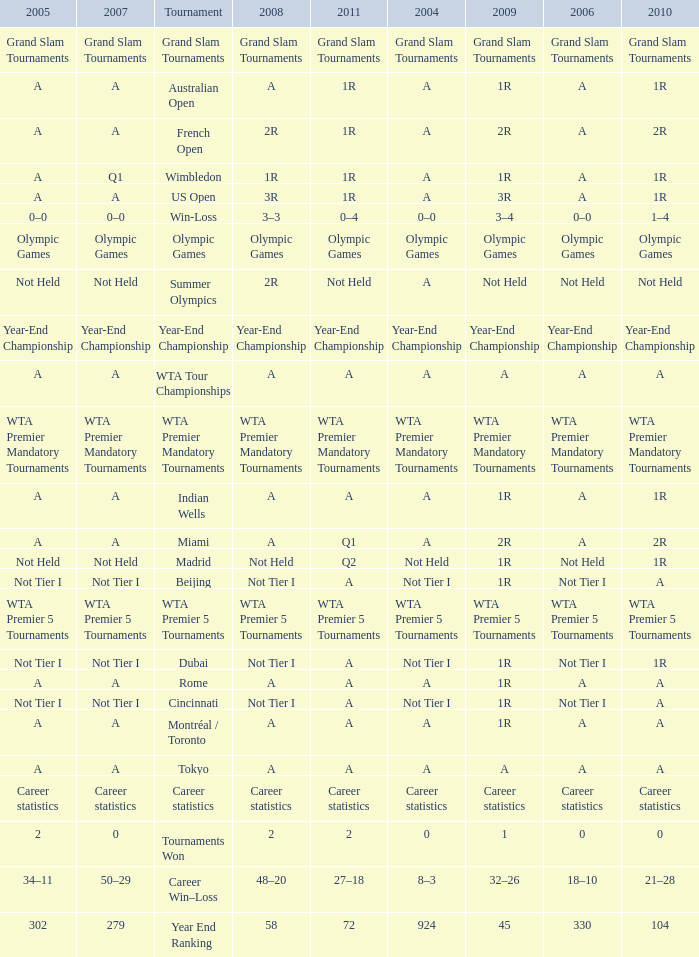What is 2004, when 2005 is "Not Tier I"? Not Tier I, Not Tier I, Not Tier I. 